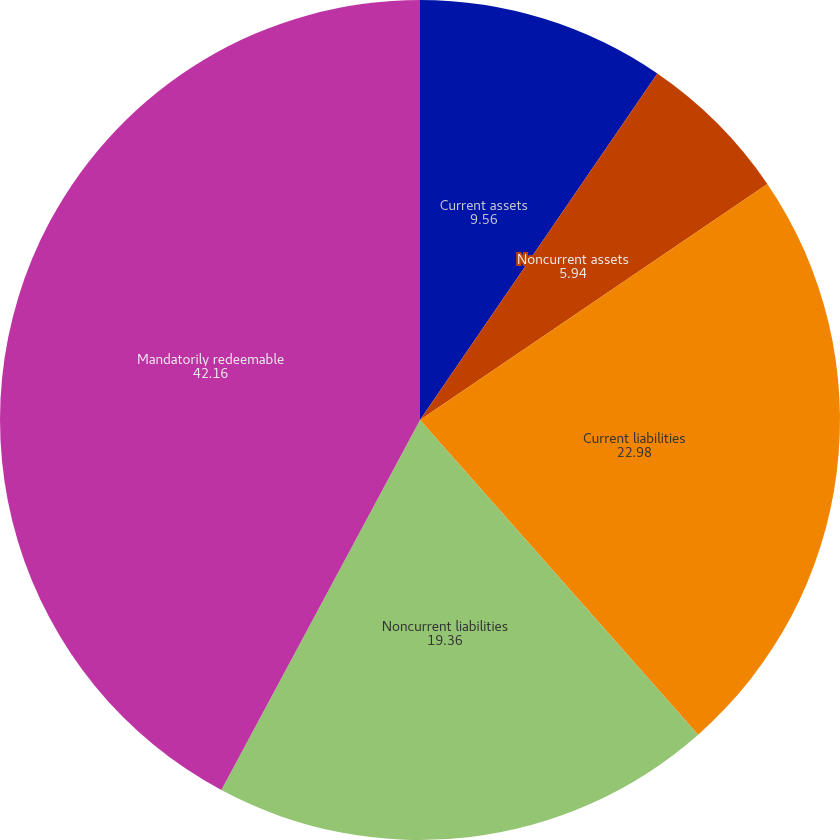Convert chart. <chart><loc_0><loc_0><loc_500><loc_500><pie_chart><fcel>Current assets<fcel>Noncurrent assets<fcel>Current liabilities<fcel>Noncurrent liabilities<fcel>Mandatorily redeemable<nl><fcel>9.56%<fcel>5.94%<fcel>22.98%<fcel>19.36%<fcel>42.16%<nl></chart> 